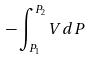<formula> <loc_0><loc_0><loc_500><loc_500>- \int _ { P _ { 1 } } ^ { P _ { 2 } } V d P</formula> 